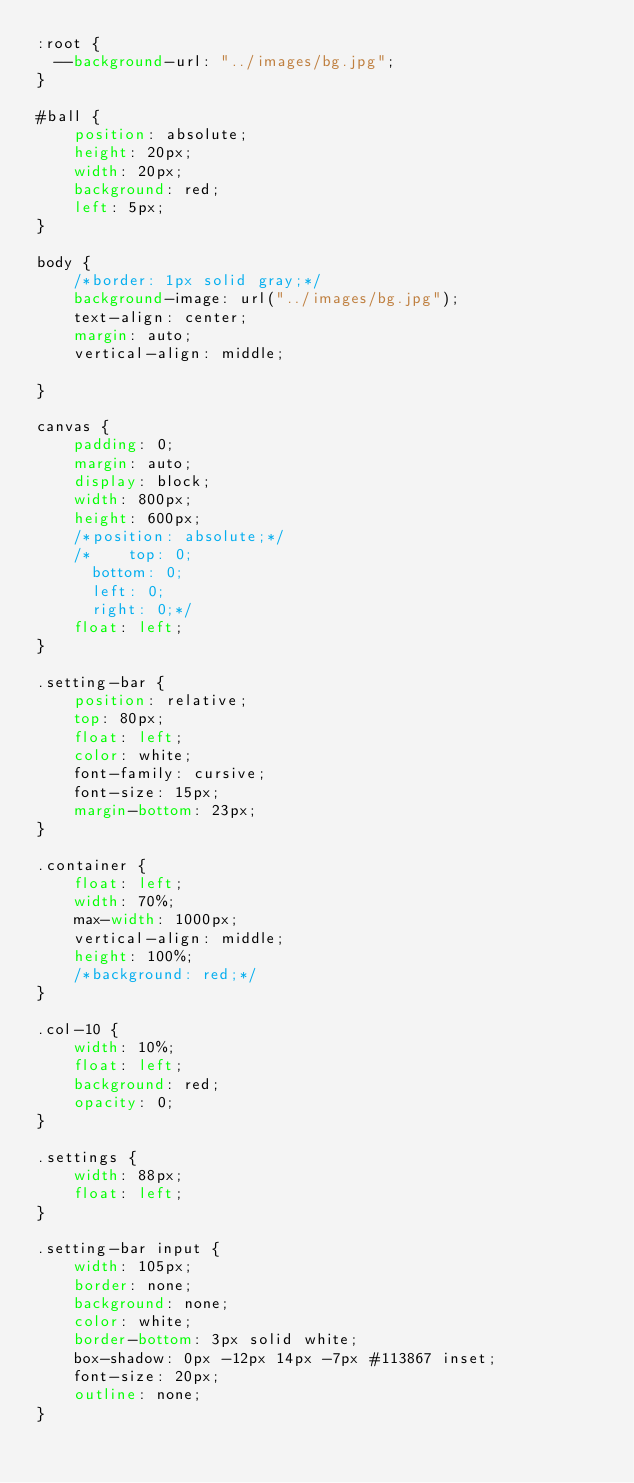Convert code to text. <code><loc_0><loc_0><loc_500><loc_500><_CSS_>:root {
	--background-url: "../images/bg.jpg";
}

#ball {
    position: absolute;
    height: 20px;
    width: 20px;
    background: red;
    left: 5px;
}

body {
    /*border: 1px solid gray;*/
    background-image: url("../images/bg.jpg");
    text-align: center;
    margin: auto;
    vertical-align: middle;

}

canvas {
    padding: 0;
    margin: auto;
    display: block;
    width: 800px;
    height: 600px;
    /*position: absolute;*/
    /*    top: 0;
	    bottom: 0;
	    left: 0;
	    right: 0;*/
    float: left;
}

.setting-bar {
    position: relative;
    top: 80px;
    float: left;
    color: white;
    font-family: cursive;
    font-size: 15px;
    margin-bottom: 23px;
}

.container {
    float: left;
    width: 70%;
    max-width: 1000px;
    vertical-align: middle;
    height: 100%;
    /*background: red;*/
}

.col-10 {
    width: 10%;
    float: left;
    background: red;
    opacity: 0;
}

.settings {
    width: 88px;
    float: left;
}

.setting-bar input {
    width: 105px;
    border: none;
    background: none;
    color: white;
    border-bottom: 3px solid white;
    box-shadow: 0px -12px 14px -7px #113867 inset;
    font-size: 20px;
    outline: none;
}</code> 